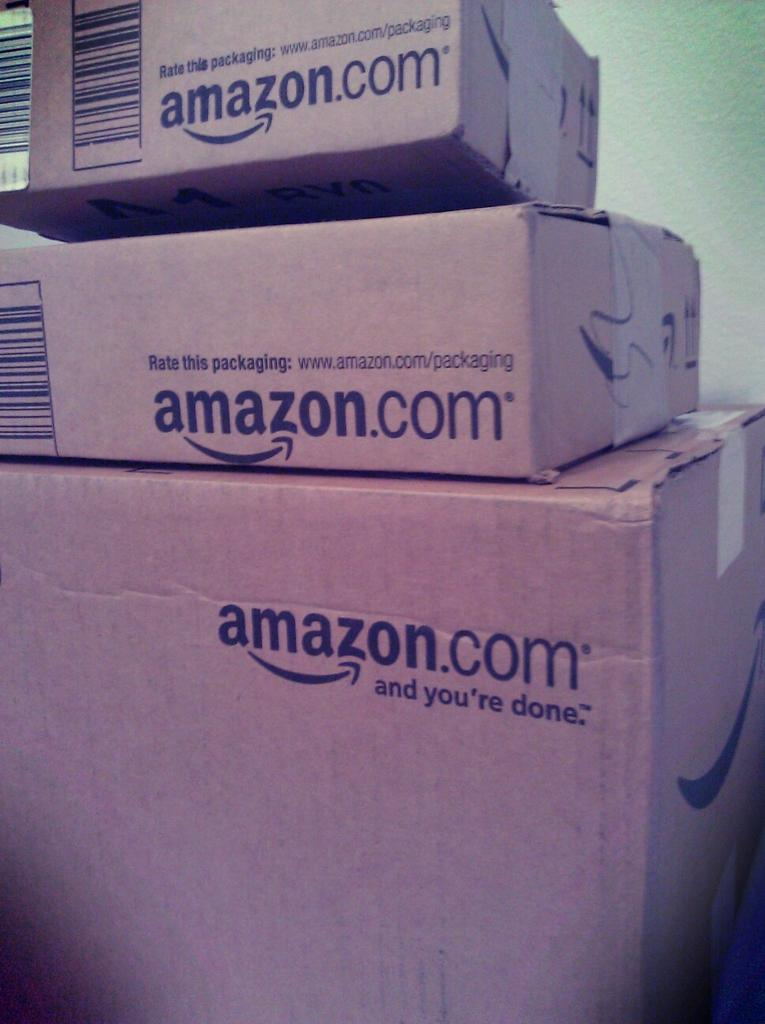<image>
Provide a brief description of the given image. Three boxes have the Amazon logo with its website. 